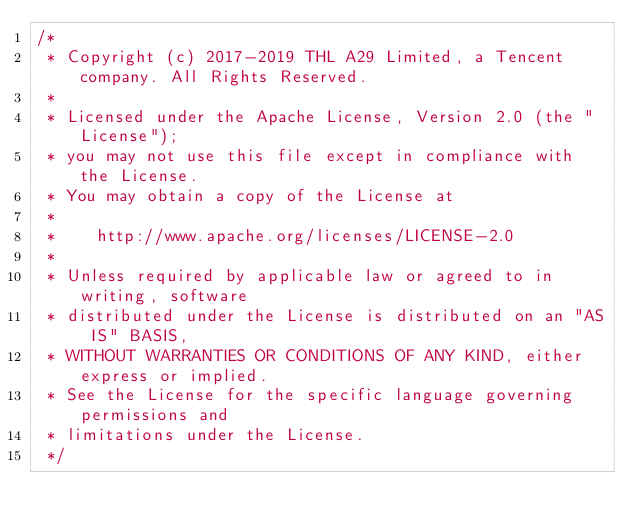<code> <loc_0><loc_0><loc_500><loc_500><_C++_>/*
 * Copyright (c) 2017-2019 THL A29 Limited, a Tencent company. All Rights Reserved.
 *
 * Licensed under the Apache License, Version 2.0 (the "License");
 * you may not use this file except in compliance with the License.
 * You may obtain a copy of the License at
 *
 *    http://www.apache.org/licenses/LICENSE-2.0
 *
 * Unless required by applicable law or agreed to in writing, software
 * distributed under the License is distributed on an "AS IS" BASIS,
 * WITHOUT WARRANTIES OR CONDITIONS OF ANY KIND, either express or implied.
 * See the License for the specific language governing permissions and
 * limitations under the License.
 */
</code> 